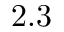<formula> <loc_0><loc_0><loc_500><loc_500>2 . 3</formula> 